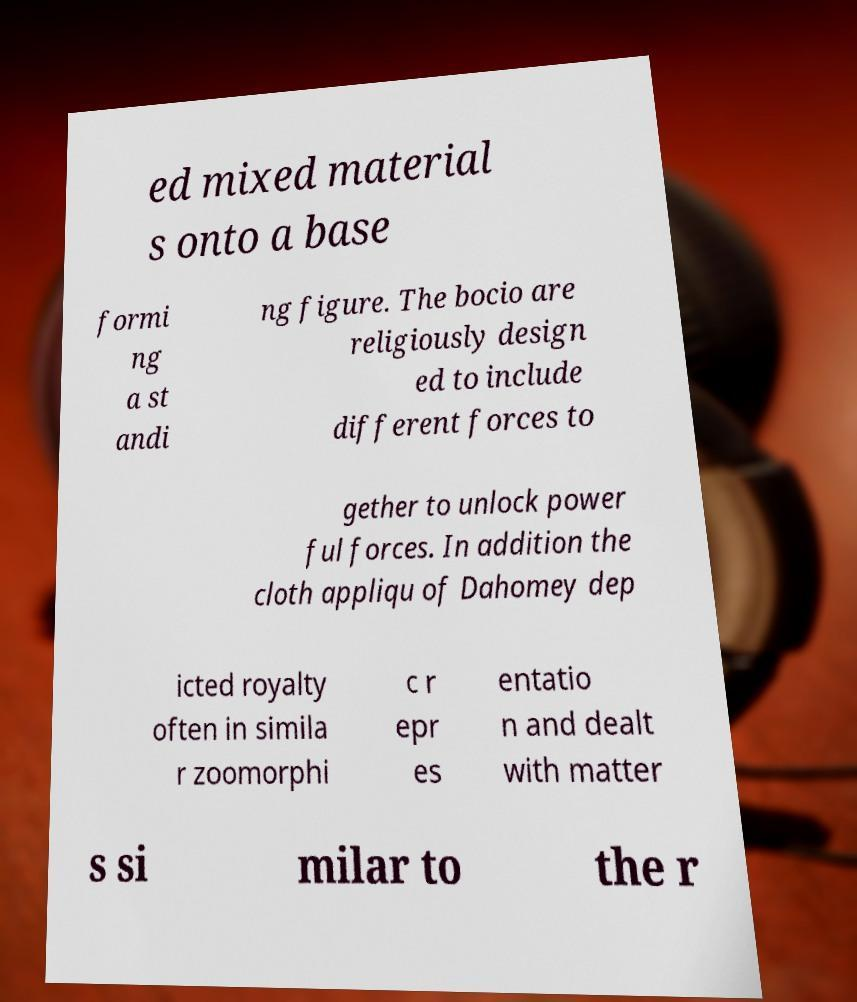There's text embedded in this image that I need extracted. Can you transcribe it verbatim? ed mixed material s onto a base formi ng a st andi ng figure. The bocio are religiously design ed to include different forces to gether to unlock power ful forces. In addition the cloth appliqu of Dahomey dep icted royalty often in simila r zoomorphi c r epr es entatio n and dealt with matter s si milar to the r 